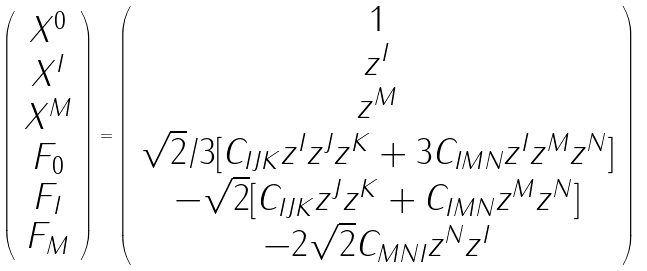Convert formula to latex. <formula><loc_0><loc_0><loc_500><loc_500>\left ( \begin{array} { c } X ^ { 0 } \\ X ^ { I } \\ X ^ { M } \\ F _ { 0 } \\ F _ { I } \\ F _ { M } \end{array} \right ) = \left ( \begin{array} { c } 1 \\ z ^ { I } \\ z ^ { M } \\ \sqrt { 2 } / 3 [ C _ { I J K } z ^ { I } z ^ { J } z ^ { K } + 3 C _ { I M N } z ^ { I } z ^ { M } z ^ { N } ] \\ - \sqrt { 2 } [ C _ { I J K } z ^ { J } z ^ { K } + C _ { I M N } z ^ { M } z ^ { N } ] \\ - 2 \sqrt { 2 } C _ { M N I } z ^ { N } z ^ { I } \end{array} \right )</formula> 